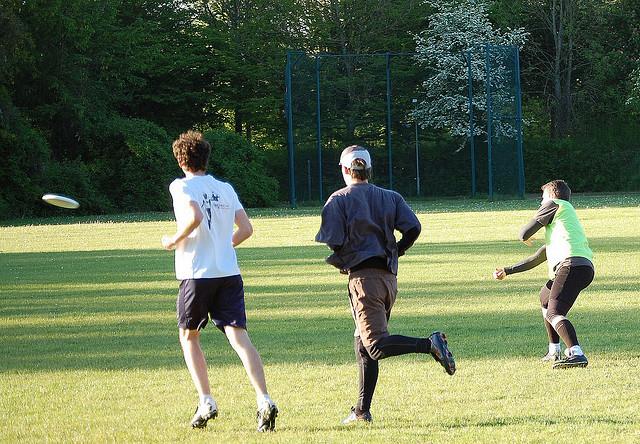What is green?
Give a very brief answer. Grass. Is it sunny?
Give a very brief answer. Yes. Who threw the frisbee?
Concise answer only. Man on right. What sport is this?
Give a very brief answer. Frisbee. How many people are in the photo?
Be succinct. 3. 